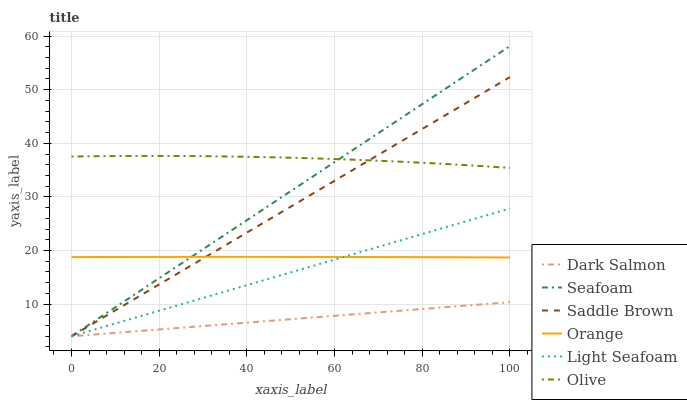Does Seafoam have the minimum area under the curve?
Answer yes or no. No. Does Seafoam have the maximum area under the curve?
Answer yes or no. No. Is Seafoam the smoothest?
Answer yes or no. No. Is Seafoam the roughest?
Answer yes or no. No. Does Olive have the lowest value?
Answer yes or no. No. Does Olive have the highest value?
Answer yes or no. No. Is Dark Salmon less than Olive?
Answer yes or no. Yes. Is Orange greater than Dark Salmon?
Answer yes or no. Yes. Does Dark Salmon intersect Olive?
Answer yes or no. No. 